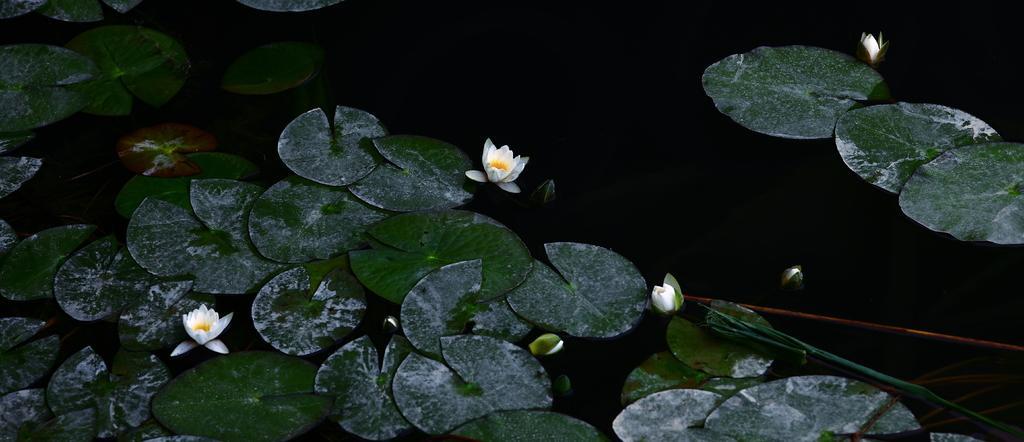Could you give a brief overview of what you see in this image? In this image, I can see the leaves and lotus flowers, which are floating on the water. 